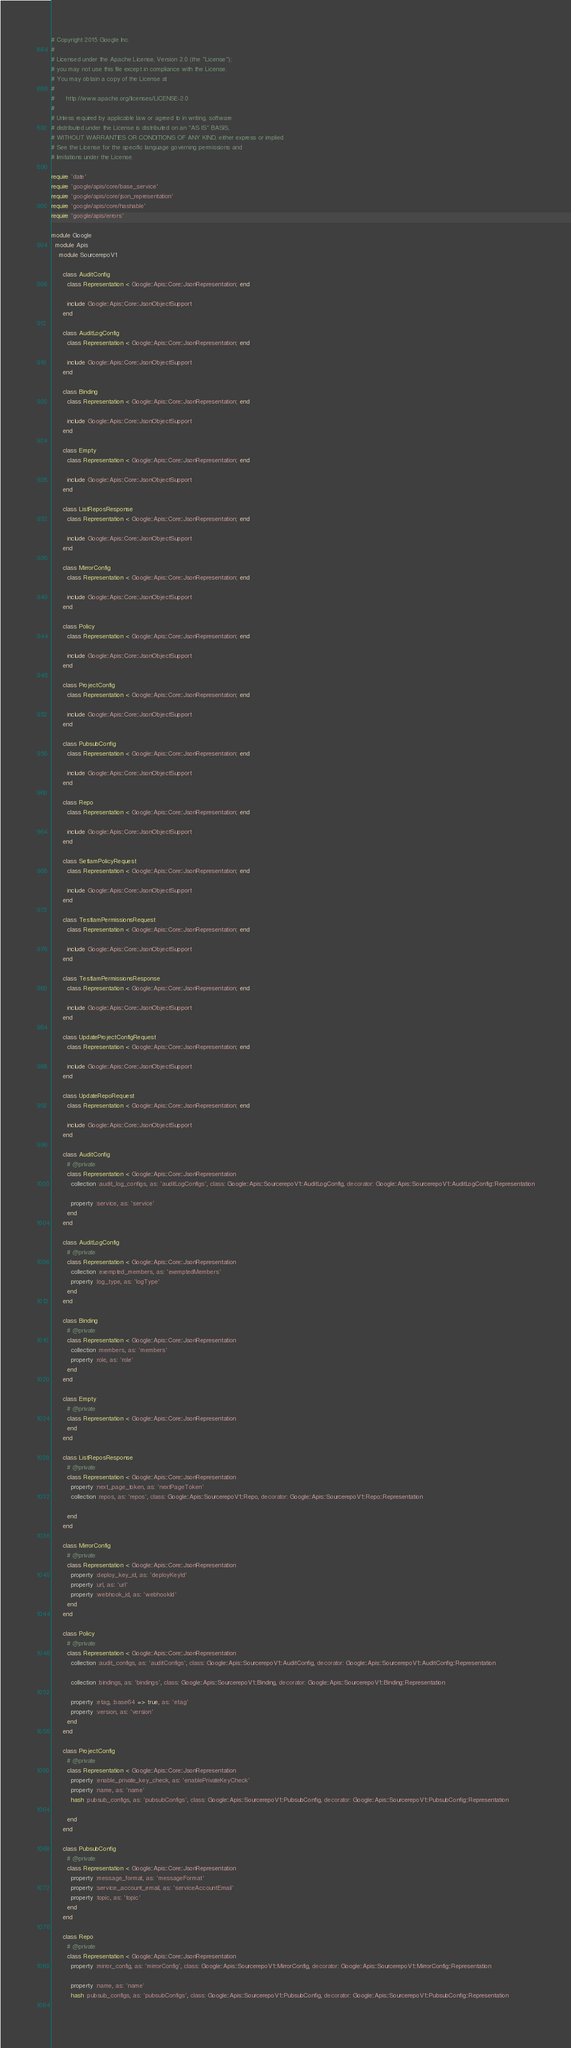<code> <loc_0><loc_0><loc_500><loc_500><_Ruby_># Copyright 2015 Google Inc.
#
# Licensed under the Apache License, Version 2.0 (the "License");
# you may not use this file except in compliance with the License.
# You may obtain a copy of the License at
#
#      http://www.apache.org/licenses/LICENSE-2.0
#
# Unless required by applicable law or agreed to in writing, software
# distributed under the License is distributed on an "AS IS" BASIS,
# WITHOUT WARRANTIES OR CONDITIONS OF ANY KIND, either express or implied.
# See the License for the specific language governing permissions and
# limitations under the License.

require 'date'
require 'google/apis/core/base_service'
require 'google/apis/core/json_representation'
require 'google/apis/core/hashable'
require 'google/apis/errors'

module Google
  module Apis
    module SourcerepoV1
      
      class AuditConfig
        class Representation < Google::Apis::Core::JsonRepresentation; end
      
        include Google::Apis::Core::JsonObjectSupport
      end
      
      class AuditLogConfig
        class Representation < Google::Apis::Core::JsonRepresentation; end
      
        include Google::Apis::Core::JsonObjectSupport
      end
      
      class Binding
        class Representation < Google::Apis::Core::JsonRepresentation; end
      
        include Google::Apis::Core::JsonObjectSupport
      end
      
      class Empty
        class Representation < Google::Apis::Core::JsonRepresentation; end
      
        include Google::Apis::Core::JsonObjectSupport
      end
      
      class ListReposResponse
        class Representation < Google::Apis::Core::JsonRepresentation; end
      
        include Google::Apis::Core::JsonObjectSupport
      end
      
      class MirrorConfig
        class Representation < Google::Apis::Core::JsonRepresentation; end
      
        include Google::Apis::Core::JsonObjectSupport
      end
      
      class Policy
        class Representation < Google::Apis::Core::JsonRepresentation; end
      
        include Google::Apis::Core::JsonObjectSupport
      end
      
      class ProjectConfig
        class Representation < Google::Apis::Core::JsonRepresentation; end
      
        include Google::Apis::Core::JsonObjectSupport
      end
      
      class PubsubConfig
        class Representation < Google::Apis::Core::JsonRepresentation; end
      
        include Google::Apis::Core::JsonObjectSupport
      end
      
      class Repo
        class Representation < Google::Apis::Core::JsonRepresentation; end
      
        include Google::Apis::Core::JsonObjectSupport
      end
      
      class SetIamPolicyRequest
        class Representation < Google::Apis::Core::JsonRepresentation; end
      
        include Google::Apis::Core::JsonObjectSupport
      end
      
      class TestIamPermissionsRequest
        class Representation < Google::Apis::Core::JsonRepresentation; end
      
        include Google::Apis::Core::JsonObjectSupport
      end
      
      class TestIamPermissionsResponse
        class Representation < Google::Apis::Core::JsonRepresentation; end
      
        include Google::Apis::Core::JsonObjectSupport
      end
      
      class UpdateProjectConfigRequest
        class Representation < Google::Apis::Core::JsonRepresentation; end
      
        include Google::Apis::Core::JsonObjectSupport
      end
      
      class UpdateRepoRequest
        class Representation < Google::Apis::Core::JsonRepresentation; end
      
        include Google::Apis::Core::JsonObjectSupport
      end
      
      class AuditConfig
        # @private
        class Representation < Google::Apis::Core::JsonRepresentation
          collection :audit_log_configs, as: 'auditLogConfigs', class: Google::Apis::SourcerepoV1::AuditLogConfig, decorator: Google::Apis::SourcerepoV1::AuditLogConfig::Representation
      
          property :service, as: 'service'
        end
      end
      
      class AuditLogConfig
        # @private
        class Representation < Google::Apis::Core::JsonRepresentation
          collection :exempted_members, as: 'exemptedMembers'
          property :log_type, as: 'logType'
        end
      end
      
      class Binding
        # @private
        class Representation < Google::Apis::Core::JsonRepresentation
          collection :members, as: 'members'
          property :role, as: 'role'
        end
      end
      
      class Empty
        # @private
        class Representation < Google::Apis::Core::JsonRepresentation
        end
      end
      
      class ListReposResponse
        # @private
        class Representation < Google::Apis::Core::JsonRepresentation
          property :next_page_token, as: 'nextPageToken'
          collection :repos, as: 'repos', class: Google::Apis::SourcerepoV1::Repo, decorator: Google::Apis::SourcerepoV1::Repo::Representation
      
        end
      end
      
      class MirrorConfig
        # @private
        class Representation < Google::Apis::Core::JsonRepresentation
          property :deploy_key_id, as: 'deployKeyId'
          property :url, as: 'url'
          property :webhook_id, as: 'webhookId'
        end
      end
      
      class Policy
        # @private
        class Representation < Google::Apis::Core::JsonRepresentation
          collection :audit_configs, as: 'auditConfigs', class: Google::Apis::SourcerepoV1::AuditConfig, decorator: Google::Apis::SourcerepoV1::AuditConfig::Representation
      
          collection :bindings, as: 'bindings', class: Google::Apis::SourcerepoV1::Binding, decorator: Google::Apis::SourcerepoV1::Binding::Representation
      
          property :etag, :base64 => true, as: 'etag'
          property :version, as: 'version'
        end
      end
      
      class ProjectConfig
        # @private
        class Representation < Google::Apis::Core::JsonRepresentation
          property :enable_private_key_check, as: 'enablePrivateKeyCheck'
          property :name, as: 'name'
          hash :pubsub_configs, as: 'pubsubConfigs', class: Google::Apis::SourcerepoV1::PubsubConfig, decorator: Google::Apis::SourcerepoV1::PubsubConfig::Representation
      
        end
      end
      
      class PubsubConfig
        # @private
        class Representation < Google::Apis::Core::JsonRepresentation
          property :message_format, as: 'messageFormat'
          property :service_account_email, as: 'serviceAccountEmail'
          property :topic, as: 'topic'
        end
      end
      
      class Repo
        # @private
        class Representation < Google::Apis::Core::JsonRepresentation
          property :mirror_config, as: 'mirrorConfig', class: Google::Apis::SourcerepoV1::MirrorConfig, decorator: Google::Apis::SourcerepoV1::MirrorConfig::Representation
      
          property :name, as: 'name'
          hash :pubsub_configs, as: 'pubsubConfigs', class: Google::Apis::SourcerepoV1::PubsubConfig, decorator: Google::Apis::SourcerepoV1::PubsubConfig::Representation
      </code> 